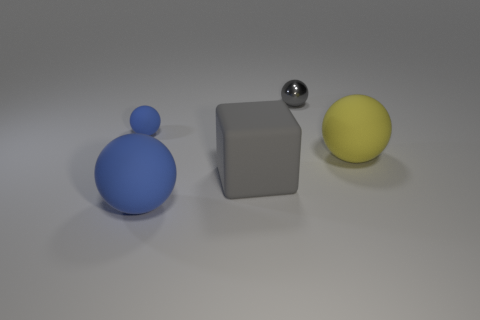Are there more big blue objects left of the small blue matte ball than big yellow matte objects that are behind the tiny shiny ball?
Make the answer very short. No. Is the large gray block made of the same material as the yellow thing?
Ensure brevity in your answer.  Yes. The large matte thing that is both to the left of the metallic ball and behind the large blue sphere has what shape?
Your answer should be very brief. Cube. There is a big gray object that is made of the same material as the small blue thing; what shape is it?
Ensure brevity in your answer.  Cube. Are there any tiny blue shiny blocks?
Ensure brevity in your answer.  No. Is there a small metal thing in front of the big ball in front of the gray rubber object?
Give a very brief answer. No. There is another large thing that is the same shape as the large yellow object; what is its material?
Make the answer very short. Rubber. Is the number of big gray shiny cylinders greater than the number of large matte objects?
Make the answer very short. No. There is a metal thing; does it have the same color as the large matte object left of the big gray cube?
Your answer should be compact. No. What is the color of the thing that is both behind the big yellow sphere and in front of the small gray shiny sphere?
Give a very brief answer. Blue. 